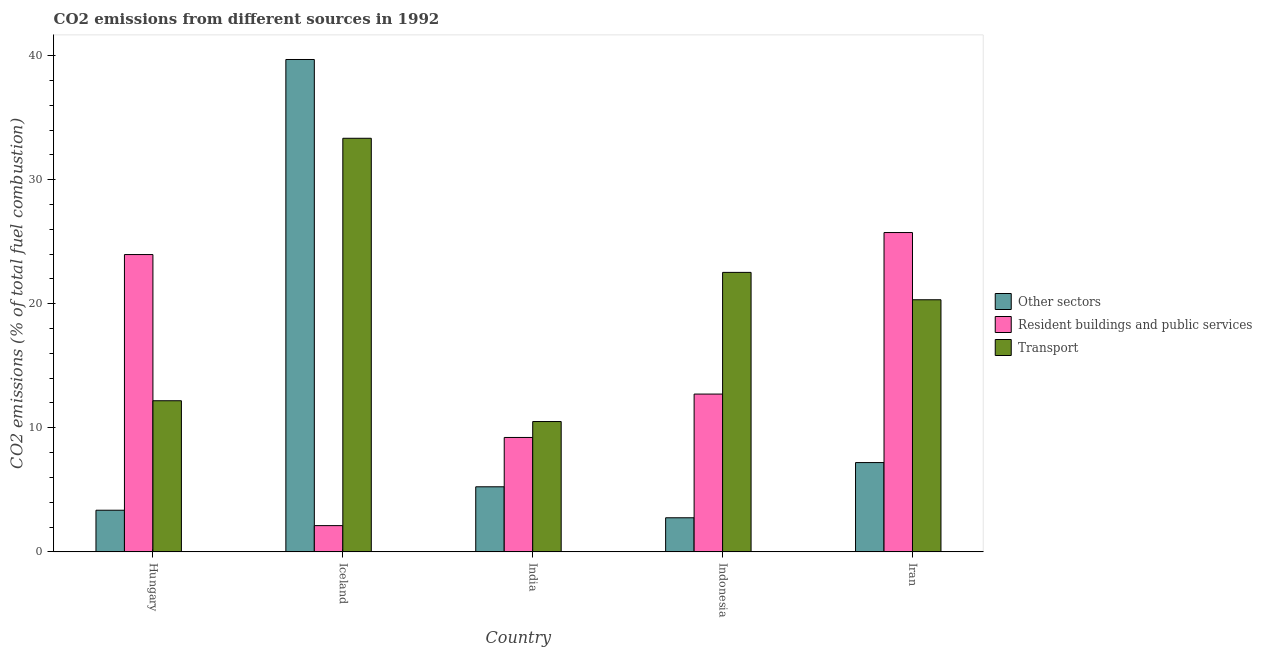How many different coloured bars are there?
Keep it short and to the point. 3. How many groups of bars are there?
Provide a succinct answer. 5. Are the number of bars on each tick of the X-axis equal?
Offer a very short reply. Yes. How many bars are there on the 1st tick from the left?
Offer a terse response. 3. How many bars are there on the 2nd tick from the right?
Offer a very short reply. 3. What is the label of the 3rd group of bars from the left?
Offer a very short reply. India. In how many cases, is the number of bars for a given country not equal to the number of legend labels?
Your answer should be very brief. 0. What is the percentage of co2 emissions from transport in Iran?
Offer a terse response. 20.32. Across all countries, what is the maximum percentage of co2 emissions from resident buildings and public services?
Keep it short and to the point. 25.74. Across all countries, what is the minimum percentage of co2 emissions from transport?
Provide a succinct answer. 10.5. In which country was the percentage of co2 emissions from transport maximum?
Give a very brief answer. Iceland. What is the total percentage of co2 emissions from transport in the graph?
Your answer should be compact. 98.86. What is the difference between the percentage of co2 emissions from resident buildings and public services in Hungary and that in Iran?
Offer a very short reply. -1.77. What is the difference between the percentage of co2 emissions from transport in Indonesia and the percentage of co2 emissions from resident buildings and public services in India?
Ensure brevity in your answer.  13.31. What is the average percentage of co2 emissions from other sectors per country?
Offer a terse response. 11.65. What is the difference between the percentage of co2 emissions from transport and percentage of co2 emissions from resident buildings and public services in Iran?
Offer a terse response. -5.42. In how many countries, is the percentage of co2 emissions from other sectors greater than 10 %?
Make the answer very short. 1. What is the ratio of the percentage of co2 emissions from transport in Iceland to that in India?
Your answer should be compact. 3.17. Is the difference between the percentage of co2 emissions from resident buildings and public services in Hungary and Iceland greater than the difference between the percentage of co2 emissions from transport in Hungary and Iceland?
Make the answer very short. Yes. What is the difference between the highest and the second highest percentage of co2 emissions from other sectors?
Offer a terse response. 32.48. What is the difference between the highest and the lowest percentage of co2 emissions from other sectors?
Your response must be concise. 36.93. In how many countries, is the percentage of co2 emissions from resident buildings and public services greater than the average percentage of co2 emissions from resident buildings and public services taken over all countries?
Ensure brevity in your answer.  2. Is the sum of the percentage of co2 emissions from transport in Indonesia and Iran greater than the maximum percentage of co2 emissions from other sectors across all countries?
Your answer should be compact. Yes. What does the 3rd bar from the left in India represents?
Ensure brevity in your answer.  Transport. What does the 3rd bar from the right in Indonesia represents?
Make the answer very short. Other sectors. How many bars are there?
Provide a short and direct response. 15. How many countries are there in the graph?
Provide a short and direct response. 5. What is the difference between two consecutive major ticks on the Y-axis?
Keep it short and to the point. 10. Where does the legend appear in the graph?
Give a very brief answer. Center right. What is the title of the graph?
Provide a short and direct response. CO2 emissions from different sources in 1992. What is the label or title of the X-axis?
Your response must be concise. Country. What is the label or title of the Y-axis?
Your answer should be very brief. CO2 emissions (% of total fuel combustion). What is the CO2 emissions (% of total fuel combustion) in Other sectors in Hungary?
Offer a very short reply. 3.36. What is the CO2 emissions (% of total fuel combustion) of Resident buildings and public services in Hungary?
Your answer should be very brief. 23.96. What is the CO2 emissions (% of total fuel combustion) in Transport in Hungary?
Offer a terse response. 12.18. What is the CO2 emissions (% of total fuel combustion) of Other sectors in Iceland?
Offer a very short reply. 39.68. What is the CO2 emissions (% of total fuel combustion) in Resident buildings and public services in Iceland?
Your answer should be compact. 2.12. What is the CO2 emissions (% of total fuel combustion) in Transport in Iceland?
Provide a short and direct response. 33.33. What is the CO2 emissions (% of total fuel combustion) in Other sectors in India?
Your answer should be very brief. 5.25. What is the CO2 emissions (% of total fuel combustion) of Resident buildings and public services in India?
Ensure brevity in your answer.  9.22. What is the CO2 emissions (% of total fuel combustion) of Transport in India?
Keep it short and to the point. 10.5. What is the CO2 emissions (% of total fuel combustion) of Other sectors in Indonesia?
Your response must be concise. 2.75. What is the CO2 emissions (% of total fuel combustion) of Resident buildings and public services in Indonesia?
Your response must be concise. 12.72. What is the CO2 emissions (% of total fuel combustion) in Transport in Indonesia?
Your response must be concise. 22.53. What is the CO2 emissions (% of total fuel combustion) in Other sectors in Iran?
Provide a short and direct response. 7.2. What is the CO2 emissions (% of total fuel combustion) of Resident buildings and public services in Iran?
Make the answer very short. 25.74. What is the CO2 emissions (% of total fuel combustion) of Transport in Iran?
Keep it short and to the point. 20.32. Across all countries, what is the maximum CO2 emissions (% of total fuel combustion) in Other sectors?
Provide a succinct answer. 39.68. Across all countries, what is the maximum CO2 emissions (% of total fuel combustion) of Resident buildings and public services?
Offer a very short reply. 25.74. Across all countries, what is the maximum CO2 emissions (% of total fuel combustion) of Transport?
Give a very brief answer. 33.33. Across all countries, what is the minimum CO2 emissions (% of total fuel combustion) in Other sectors?
Provide a succinct answer. 2.75. Across all countries, what is the minimum CO2 emissions (% of total fuel combustion) in Resident buildings and public services?
Ensure brevity in your answer.  2.12. Across all countries, what is the minimum CO2 emissions (% of total fuel combustion) of Transport?
Your response must be concise. 10.5. What is the total CO2 emissions (% of total fuel combustion) in Other sectors in the graph?
Your response must be concise. 58.23. What is the total CO2 emissions (% of total fuel combustion) of Resident buildings and public services in the graph?
Your answer should be very brief. 73.75. What is the total CO2 emissions (% of total fuel combustion) in Transport in the graph?
Your response must be concise. 98.86. What is the difference between the CO2 emissions (% of total fuel combustion) in Other sectors in Hungary and that in Iceland?
Keep it short and to the point. -36.33. What is the difference between the CO2 emissions (% of total fuel combustion) in Resident buildings and public services in Hungary and that in Iceland?
Give a very brief answer. 21.85. What is the difference between the CO2 emissions (% of total fuel combustion) of Transport in Hungary and that in Iceland?
Ensure brevity in your answer.  -21.15. What is the difference between the CO2 emissions (% of total fuel combustion) of Other sectors in Hungary and that in India?
Provide a succinct answer. -1.89. What is the difference between the CO2 emissions (% of total fuel combustion) in Resident buildings and public services in Hungary and that in India?
Offer a very short reply. 14.74. What is the difference between the CO2 emissions (% of total fuel combustion) of Transport in Hungary and that in India?
Make the answer very short. 1.68. What is the difference between the CO2 emissions (% of total fuel combustion) in Other sectors in Hungary and that in Indonesia?
Offer a terse response. 0.61. What is the difference between the CO2 emissions (% of total fuel combustion) in Resident buildings and public services in Hungary and that in Indonesia?
Your response must be concise. 11.24. What is the difference between the CO2 emissions (% of total fuel combustion) of Transport in Hungary and that in Indonesia?
Provide a succinct answer. -10.35. What is the difference between the CO2 emissions (% of total fuel combustion) of Other sectors in Hungary and that in Iran?
Offer a very short reply. -3.84. What is the difference between the CO2 emissions (% of total fuel combustion) in Resident buildings and public services in Hungary and that in Iran?
Ensure brevity in your answer.  -1.77. What is the difference between the CO2 emissions (% of total fuel combustion) in Transport in Hungary and that in Iran?
Offer a terse response. -8.14. What is the difference between the CO2 emissions (% of total fuel combustion) of Other sectors in Iceland and that in India?
Provide a succinct answer. 34.44. What is the difference between the CO2 emissions (% of total fuel combustion) in Resident buildings and public services in Iceland and that in India?
Your response must be concise. -7.1. What is the difference between the CO2 emissions (% of total fuel combustion) of Transport in Iceland and that in India?
Ensure brevity in your answer.  22.83. What is the difference between the CO2 emissions (% of total fuel combustion) of Other sectors in Iceland and that in Indonesia?
Your response must be concise. 36.93. What is the difference between the CO2 emissions (% of total fuel combustion) in Resident buildings and public services in Iceland and that in Indonesia?
Keep it short and to the point. -10.6. What is the difference between the CO2 emissions (% of total fuel combustion) in Transport in Iceland and that in Indonesia?
Keep it short and to the point. 10.81. What is the difference between the CO2 emissions (% of total fuel combustion) of Other sectors in Iceland and that in Iran?
Keep it short and to the point. 32.48. What is the difference between the CO2 emissions (% of total fuel combustion) in Resident buildings and public services in Iceland and that in Iran?
Give a very brief answer. -23.62. What is the difference between the CO2 emissions (% of total fuel combustion) of Transport in Iceland and that in Iran?
Give a very brief answer. 13.01. What is the difference between the CO2 emissions (% of total fuel combustion) of Other sectors in India and that in Indonesia?
Make the answer very short. 2.5. What is the difference between the CO2 emissions (% of total fuel combustion) of Resident buildings and public services in India and that in Indonesia?
Keep it short and to the point. -3.5. What is the difference between the CO2 emissions (% of total fuel combustion) in Transport in India and that in Indonesia?
Your response must be concise. -12.02. What is the difference between the CO2 emissions (% of total fuel combustion) in Other sectors in India and that in Iran?
Offer a very short reply. -1.95. What is the difference between the CO2 emissions (% of total fuel combustion) of Resident buildings and public services in India and that in Iran?
Offer a terse response. -16.52. What is the difference between the CO2 emissions (% of total fuel combustion) in Transport in India and that in Iran?
Your answer should be very brief. -9.82. What is the difference between the CO2 emissions (% of total fuel combustion) in Other sectors in Indonesia and that in Iran?
Offer a very short reply. -4.45. What is the difference between the CO2 emissions (% of total fuel combustion) of Resident buildings and public services in Indonesia and that in Iran?
Provide a succinct answer. -13.02. What is the difference between the CO2 emissions (% of total fuel combustion) of Transport in Indonesia and that in Iran?
Your response must be concise. 2.21. What is the difference between the CO2 emissions (% of total fuel combustion) of Other sectors in Hungary and the CO2 emissions (% of total fuel combustion) of Resident buildings and public services in Iceland?
Your answer should be very brief. 1.24. What is the difference between the CO2 emissions (% of total fuel combustion) in Other sectors in Hungary and the CO2 emissions (% of total fuel combustion) in Transport in Iceland?
Your response must be concise. -29.98. What is the difference between the CO2 emissions (% of total fuel combustion) of Resident buildings and public services in Hungary and the CO2 emissions (% of total fuel combustion) of Transport in Iceland?
Offer a terse response. -9.37. What is the difference between the CO2 emissions (% of total fuel combustion) of Other sectors in Hungary and the CO2 emissions (% of total fuel combustion) of Resident buildings and public services in India?
Give a very brief answer. -5.86. What is the difference between the CO2 emissions (% of total fuel combustion) of Other sectors in Hungary and the CO2 emissions (% of total fuel combustion) of Transport in India?
Your response must be concise. -7.15. What is the difference between the CO2 emissions (% of total fuel combustion) in Resident buildings and public services in Hungary and the CO2 emissions (% of total fuel combustion) in Transport in India?
Make the answer very short. 13.46. What is the difference between the CO2 emissions (% of total fuel combustion) in Other sectors in Hungary and the CO2 emissions (% of total fuel combustion) in Resident buildings and public services in Indonesia?
Provide a succinct answer. -9.36. What is the difference between the CO2 emissions (% of total fuel combustion) of Other sectors in Hungary and the CO2 emissions (% of total fuel combustion) of Transport in Indonesia?
Your answer should be compact. -19.17. What is the difference between the CO2 emissions (% of total fuel combustion) in Resident buildings and public services in Hungary and the CO2 emissions (% of total fuel combustion) in Transport in Indonesia?
Keep it short and to the point. 1.44. What is the difference between the CO2 emissions (% of total fuel combustion) of Other sectors in Hungary and the CO2 emissions (% of total fuel combustion) of Resident buildings and public services in Iran?
Keep it short and to the point. -22.38. What is the difference between the CO2 emissions (% of total fuel combustion) in Other sectors in Hungary and the CO2 emissions (% of total fuel combustion) in Transport in Iran?
Make the answer very short. -16.96. What is the difference between the CO2 emissions (% of total fuel combustion) in Resident buildings and public services in Hungary and the CO2 emissions (% of total fuel combustion) in Transport in Iran?
Provide a succinct answer. 3.64. What is the difference between the CO2 emissions (% of total fuel combustion) in Other sectors in Iceland and the CO2 emissions (% of total fuel combustion) in Resident buildings and public services in India?
Offer a very short reply. 30.46. What is the difference between the CO2 emissions (% of total fuel combustion) of Other sectors in Iceland and the CO2 emissions (% of total fuel combustion) of Transport in India?
Make the answer very short. 29.18. What is the difference between the CO2 emissions (% of total fuel combustion) of Resident buildings and public services in Iceland and the CO2 emissions (% of total fuel combustion) of Transport in India?
Ensure brevity in your answer.  -8.39. What is the difference between the CO2 emissions (% of total fuel combustion) in Other sectors in Iceland and the CO2 emissions (% of total fuel combustion) in Resident buildings and public services in Indonesia?
Provide a short and direct response. 26.96. What is the difference between the CO2 emissions (% of total fuel combustion) of Other sectors in Iceland and the CO2 emissions (% of total fuel combustion) of Transport in Indonesia?
Provide a succinct answer. 17.16. What is the difference between the CO2 emissions (% of total fuel combustion) of Resident buildings and public services in Iceland and the CO2 emissions (% of total fuel combustion) of Transport in Indonesia?
Offer a very short reply. -20.41. What is the difference between the CO2 emissions (% of total fuel combustion) of Other sectors in Iceland and the CO2 emissions (% of total fuel combustion) of Resident buildings and public services in Iran?
Your response must be concise. 13.95. What is the difference between the CO2 emissions (% of total fuel combustion) in Other sectors in Iceland and the CO2 emissions (% of total fuel combustion) in Transport in Iran?
Your answer should be very brief. 19.36. What is the difference between the CO2 emissions (% of total fuel combustion) of Resident buildings and public services in Iceland and the CO2 emissions (% of total fuel combustion) of Transport in Iran?
Provide a short and direct response. -18.2. What is the difference between the CO2 emissions (% of total fuel combustion) of Other sectors in India and the CO2 emissions (% of total fuel combustion) of Resident buildings and public services in Indonesia?
Your answer should be compact. -7.47. What is the difference between the CO2 emissions (% of total fuel combustion) of Other sectors in India and the CO2 emissions (% of total fuel combustion) of Transport in Indonesia?
Your response must be concise. -17.28. What is the difference between the CO2 emissions (% of total fuel combustion) in Resident buildings and public services in India and the CO2 emissions (% of total fuel combustion) in Transport in Indonesia?
Your answer should be compact. -13.3. What is the difference between the CO2 emissions (% of total fuel combustion) in Other sectors in India and the CO2 emissions (% of total fuel combustion) in Resident buildings and public services in Iran?
Your answer should be compact. -20.49. What is the difference between the CO2 emissions (% of total fuel combustion) in Other sectors in India and the CO2 emissions (% of total fuel combustion) in Transport in Iran?
Provide a succinct answer. -15.07. What is the difference between the CO2 emissions (% of total fuel combustion) of Resident buildings and public services in India and the CO2 emissions (% of total fuel combustion) of Transport in Iran?
Offer a very short reply. -11.1. What is the difference between the CO2 emissions (% of total fuel combustion) of Other sectors in Indonesia and the CO2 emissions (% of total fuel combustion) of Resident buildings and public services in Iran?
Offer a terse response. -22.99. What is the difference between the CO2 emissions (% of total fuel combustion) in Other sectors in Indonesia and the CO2 emissions (% of total fuel combustion) in Transport in Iran?
Provide a short and direct response. -17.57. What is the difference between the CO2 emissions (% of total fuel combustion) in Resident buildings and public services in Indonesia and the CO2 emissions (% of total fuel combustion) in Transport in Iran?
Ensure brevity in your answer.  -7.6. What is the average CO2 emissions (% of total fuel combustion) in Other sectors per country?
Keep it short and to the point. 11.65. What is the average CO2 emissions (% of total fuel combustion) of Resident buildings and public services per country?
Offer a terse response. 14.75. What is the average CO2 emissions (% of total fuel combustion) in Transport per country?
Ensure brevity in your answer.  19.77. What is the difference between the CO2 emissions (% of total fuel combustion) of Other sectors and CO2 emissions (% of total fuel combustion) of Resident buildings and public services in Hungary?
Your answer should be very brief. -20.61. What is the difference between the CO2 emissions (% of total fuel combustion) of Other sectors and CO2 emissions (% of total fuel combustion) of Transport in Hungary?
Give a very brief answer. -8.82. What is the difference between the CO2 emissions (% of total fuel combustion) of Resident buildings and public services and CO2 emissions (% of total fuel combustion) of Transport in Hungary?
Provide a short and direct response. 11.78. What is the difference between the CO2 emissions (% of total fuel combustion) of Other sectors and CO2 emissions (% of total fuel combustion) of Resident buildings and public services in Iceland?
Your answer should be very brief. 37.57. What is the difference between the CO2 emissions (% of total fuel combustion) in Other sectors and CO2 emissions (% of total fuel combustion) in Transport in Iceland?
Your answer should be very brief. 6.35. What is the difference between the CO2 emissions (% of total fuel combustion) of Resident buildings and public services and CO2 emissions (% of total fuel combustion) of Transport in Iceland?
Ensure brevity in your answer.  -31.22. What is the difference between the CO2 emissions (% of total fuel combustion) of Other sectors and CO2 emissions (% of total fuel combustion) of Resident buildings and public services in India?
Your answer should be very brief. -3.97. What is the difference between the CO2 emissions (% of total fuel combustion) in Other sectors and CO2 emissions (% of total fuel combustion) in Transport in India?
Your answer should be compact. -5.26. What is the difference between the CO2 emissions (% of total fuel combustion) in Resident buildings and public services and CO2 emissions (% of total fuel combustion) in Transport in India?
Your response must be concise. -1.28. What is the difference between the CO2 emissions (% of total fuel combustion) in Other sectors and CO2 emissions (% of total fuel combustion) in Resident buildings and public services in Indonesia?
Offer a very short reply. -9.97. What is the difference between the CO2 emissions (% of total fuel combustion) in Other sectors and CO2 emissions (% of total fuel combustion) in Transport in Indonesia?
Your response must be concise. -19.78. What is the difference between the CO2 emissions (% of total fuel combustion) of Resident buildings and public services and CO2 emissions (% of total fuel combustion) of Transport in Indonesia?
Keep it short and to the point. -9.81. What is the difference between the CO2 emissions (% of total fuel combustion) of Other sectors and CO2 emissions (% of total fuel combustion) of Resident buildings and public services in Iran?
Keep it short and to the point. -18.54. What is the difference between the CO2 emissions (% of total fuel combustion) in Other sectors and CO2 emissions (% of total fuel combustion) in Transport in Iran?
Provide a short and direct response. -13.12. What is the difference between the CO2 emissions (% of total fuel combustion) of Resident buildings and public services and CO2 emissions (% of total fuel combustion) of Transport in Iran?
Ensure brevity in your answer.  5.42. What is the ratio of the CO2 emissions (% of total fuel combustion) in Other sectors in Hungary to that in Iceland?
Offer a very short reply. 0.08. What is the ratio of the CO2 emissions (% of total fuel combustion) of Resident buildings and public services in Hungary to that in Iceland?
Provide a succinct answer. 11.32. What is the ratio of the CO2 emissions (% of total fuel combustion) of Transport in Hungary to that in Iceland?
Offer a very short reply. 0.37. What is the ratio of the CO2 emissions (% of total fuel combustion) of Other sectors in Hungary to that in India?
Keep it short and to the point. 0.64. What is the ratio of the CO2 emissions (% of total fuel combustion) of Resident buildings and public services in Hungary to that in India?
Offer a terse response. 2.6. What is the ratio of the CO2 emissions (% of total fuel combustion) of Transport in Hungary to that in India?
Keep it short and to the point. 1.16. What is the ratio of the CO2 emissions (% of total fuel combustion) in Other sectors in Hungary to that in Indonesia?
Offer a very short reply. 1.22. What is the ratio of the CO2 emissions (% of total fuel combustion) in Resident buildings and public services in Hungary to that in Indonesia?
Your answer should be compact. 1.88. What is the ratio of the CO2 emissions (% of total fuel combustion) in Transport in Hungary to that in Indonesia?
Your response must be concise. 0.54. What is the ratio of the CO2 emissions (% of total fuel combustion) in Other sectors in Hungary to that in Iran?
Keep it short and to the point. 0.47. What is the ratio of the CO2 emissions (% of total fuel combustion) of Resident buildings and public services in Hungary to that in Iran?
Your answer should be compact. 0.93. What is the ratio of the CO2 emissions (% of total fuel combustion) of Transport in Hungary to that in Iran?
Your response must be concise. 0.6. What is the ratio of the CO2 emissions (% of total fuel combustion) in Other sectors in Iceland to that in India?
Provide a succinct answer. 7.56. What is the ratio of the CO2 emissions (% of total fuel combustion) in Resident buildings and public services in Iceland to that in India?
Your answer should be compact. 0.23. What is the ratio of the CO2 emissions (% of total fuel combustion) of Transport in Iceland to that in India?
Keep it short and to the point. 3.17. What is the ratio of the CO2 emissions (% of total fuel combustion) of Other sectors in Iceland to that in Indonesia?
Offer a very short reply. 14.44. What is the ratio of the CO2 emissions (% of total fuel combustion) in Resident buildings and public services in Iceland to that in Indonesia?
Offer a terse response. 0.17. What is the ratio of the CO2 emissions (% of total fuel combustion) of Transport in Iceland to that in Indonesia?
Give a very brief answer. 1.48. What is the ratio of the CO2 emissions (% of total fuel combustion) of Other sectors in Iceland to that in Iran?
Provide a succinct answer. 5.51. What is the ratio of the CO2 emissions (% of total fuel combustion) in Resident buildings and public services in Iceland to that in Iran?
Ensure brevity in your answer.  0.08. What is the ratio of the CO2 emissions (% of total fuel combustion) in Transport in Iceland to that in Iran?
Provide a short and direct response. 1.64. What is the ratio of the CO2 emissions (% of total fuel combustion) in Other sectors in India to that in Indonesia?
Your answer should be compact. 1.91. What is the ratio of the CO2 emissions (% of total fuel combustion) of Resident buildings and public services in India to that in Indonesia?
Keep it short and to the point. 0.72. What is the ratio of the CO2 emissions (% of total fuel combustion) of Transport in India to that in Indonesia?
Your response must be concise. 0.47. What is the ratio of the CO2 emissions (% of total fuel combustion) of Other sectors in India to that in Iran?
Offer a very short reply. 0.73. What is the ratio of the CO2 emissions (% of total fuel combustion) of Resident buildings and public services in India to that in Iran?
Your answer should be compact. 0.36. What is the ratio of the CO2 emissions (% of total fuel combustion) of Transport in India to that in Iran?
Offer a terse response. 0.52. What is the ratio of the CO2 emissions (% of total fuel combustion) in Other sectors in Indonesia to that in Iran?
Your response must be concise. 0.38. What is the ratio of the CO2 emissions (% of total fuel combustion) of Resident buildings and public services in Indonesia to that in Iran?
Your response must be concise. 0.49. What is the ratio of the CO2 emissions (% of total fuel combustion) of Transport in Indonesia to that in Iran?
Offer a terse response. 1.11. What is the difference between the highest and the second highest CO2 emissions (% of total fuel combustion) of Other sectors?
Your answer should be compact. 32.48. What is the difference between the highest and the second highest CO2 emissions (% of total fuel combustion) of Resident buildings and public services?
Ensure brevity in your answer.  1.77. What is the difference between the highest and the second highest CO2 emissions (% of total fuel combustion) of Transport?
Your response must be concise. 10.81. What is the difference between the highest and the lowest CO2 emissions (% of total fuel combustion) of Other sectors?
Your answer should be very brief. 36.93. What is the difference between the highest and the lowest CO2 emissions (% of total fuel combustion) of Resident buildings and public services?
Provide a succinct answer. 23.62. What is the difference between the highest and the lowest CO2 emissions (% of total fuel combustion) in Transport?
Offer a very short reply. 22.83. 